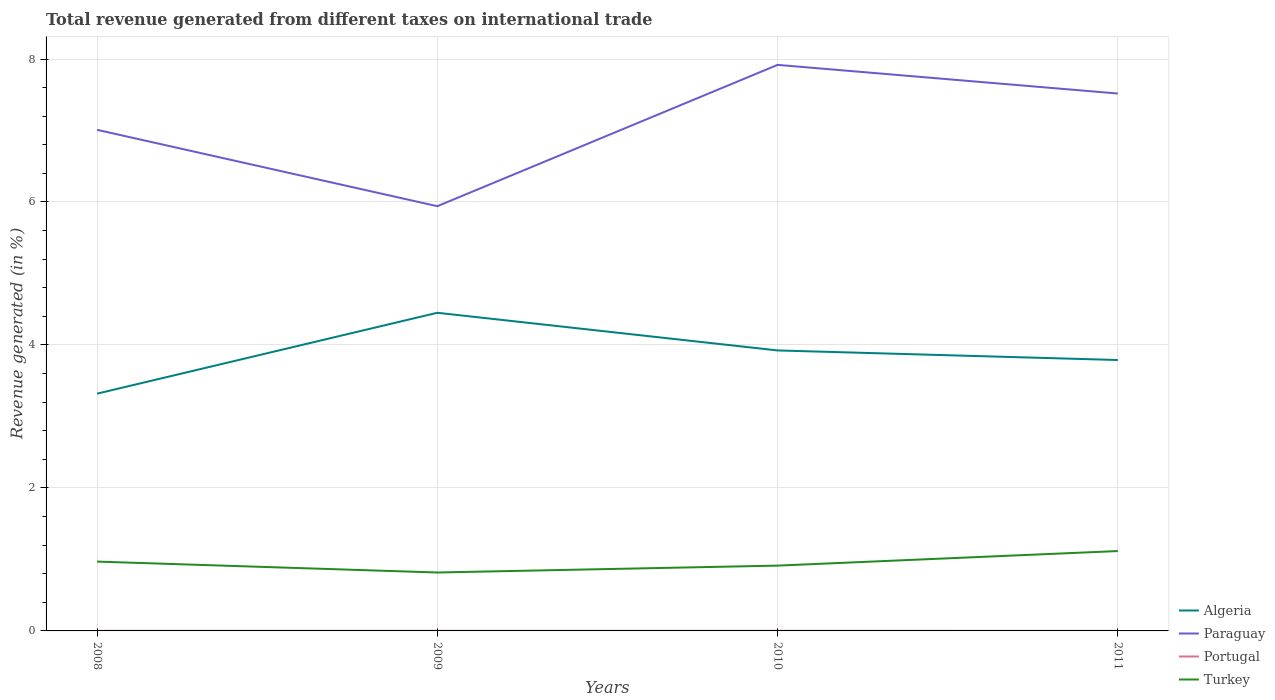How many different coloured lines are there?
Your answer should be compact. 4. Does the line corresponding to Portugal intersect with the line corresponding to Algeria?
Give a very brief answer. No. Across all years, what is the maximum total revenue generated in Paraguay?
Your answer should be compact. 5.94. What is the total total revenue generated in Algeria in the graph?
Ensure brevity in your answer.  0.53. What is the difference between the highest and the second highest total revenue generated in Turkey?
Your answer should be compact. 0.3. What is the difference between the highest and the lowest total revenue generated in Paraguay?
Ensure brevity in your answer.  2. Is the total revenue generated in Algeria strictly greater than the total revenue generated in Paraguay over the years?
Provide a succinct answer. Yes. How many lines are there?
Your response must be concise. 4. How many years are there in the graph?
Offer a very short reply. 4. Are the values on the major ticks of Y-axis written in scientific E-notation?
Your answer should be compact. No. Does the graph contain grids?
Give a very brief answer. Yes. Where does the legend appear in the graph?
Provide a succinct answer. Bottom right. How many legend labels are there?
Offer a very short reply. 4. How are the legend labels stacked?
Provide a succinct answer. Vertical. What is the title of the graph?
Provide a short and direct response. Total revenue generated from different taxes on international trade. Does "Austria" appear as one of the legend labels in the graph?
Offer a very short reply. No. What is the label or title of the X-axis?
Provide a short and direct response. Years. What is the label or title of the Y-axis?
Offer a very short reply. Revenue generated (in %). What is the Revenue generated (in %) of Algeria in 2008?
Your answer should be very brief. 3.32. What is the Revenue generated (in %) of Paraguay in 2008?
Ensure brevity in your answer.  7.01. What is the Revenue generated (in %) of Portugal in 2008?
Offer a terse response. 0. What is the Revenue generated (in %) in Turkey in 2008?
Provide a succinct answer. 0.97. What is the Revenue generated (in %) of Algeria in 2009?
Provide a succinct answer. 4.45. What is the Revenue generated (in %) in Paraguay in 2009?
Your answer should be compact. 5.94. What is the Revenue generated (in %) in Portugal in 2009?
Your answer should be compact. 0. What is the Revenue generated (in %) in Turkey in 2009?
Your response must be concise. 0.82. What is the Revenue generated (in %) of Algeria in 2010?
Give a very brief answer. 3.92. What is the Revenue generated (in %) in Paraguay in 2010?
Your answer should be compact. 7.92. What is the Revenue generated (in %) of Portugal in 2010?
Give a very brief answer. 0. What is the Revenue generated (in %) in Turkey in 2010?
Your answer should be very brief. 0.91. What is the Revenue generated (in %) of Algeria in 2011?
Offer a very short reply. 3.79. What is the Revenue generated (in %) of Paraguay in 2011?
Your response must be concise. 7.52. What is the Revenue generated (in %) in Portugal in 2011?
Offer a very short reply. 0. What is the Revenue generated (in %) in Turkey in 2011?
Your response must be concise. 1.12. Across all years, what is the maximum Revenue generated (in %) in Algeria?
Your answer should be very brief. 4.45. Across all years, what is the maximum Revenue generated (in %) of Paraguay?
Provide a short and direct response. 7.92. Across all years, what is the maximum Revenue generated (in %) of Portugal?
Ensure brevity in your answer.  0. Across all years, what is the maximum Revenue generated (in %) of Turkey?
Keep it short and to the point. 1.12. Across all years, what is the minimum Revenue generated (in %) in Algeria?
Give a very brief answer. 3.32. Across all years, what is the minimum Revenue generated (in %) of Paraguay?
Offer a terse response. 5.94. Across all years, what is the minimum Revenue generated (in %) in Portugal?
Make the answer very short. 0. Across all years, what is the minimum Revenue generated (in %) of Turkey?
Provide a succinct answer. 0.82. What is the total Revenue generated (in %) of Algeria in the graph?
Your response must be concise. 15.48. What is the total Revenue generated (in %) of Paraguay in the graph?
Offer a terse response. 28.39. What is the total Revenue generated (in %) of Portugal in the graph?
Keep it short and to the point. 0.01. What is the total Revenue generated (in %) of Turkey in the graph?
Provide a succinct answer. 3.82. What is the difference between the Revenue generated (in %) of Algeria in 2008 and that in 2009?
Offer a very short reply. -1.13. What is the difference between the Revenue generated (in %) in Paraguay in 2008 and that in 2009?
Make the answer very short. 1.07. What is the difference between the Revenue generated (in %) in Portugal in 2008 and that in 2009?
Keep it short and to the point. 0. What is the difference between the Revenue generated (in %) of Turkey in 2008 and that in 2009?
Offer a terse response. 0.15. What is the difference between the Revenue generated (in %) of Algeria in 2008 and that in 2010?
Your response must be concise. -0.6. What is the difference between the Revenue generated (in %) of Paraguay in 2008 and that in 2010?
Give a very brief answer. -0.91. What is the difference between the Revenue generated (in %) of Turkey in 2008 and that in 2010?
Give a very brief answer. 0.06. What is the difference between the Revenue generated (in %) in Algeria in 2008 and that in 2011?
Keep it short and to the point. -0.47. What is the difference between the Revenue generated (in %) of Paraguay in 2008 and that in 2011?
Give a very brief answer. -0.51. What is the difference between the Revenue generated (in %) of Portugal in 2008 and that in 2011?
Keep it short and to the point. 0. What is the difference between the Revenue generated (in %) in Turkey in 2008 and that in 2011?
Offer a very short reply. -0.15. What is the difference between the Revenue generated (in %) of Algeria in 2009 and that in 2010?
Make the answer very short. 0.53. What is the difference between the Revenue generated (in %) of Paraguay in 2009 and that in 2010?
Your answer should be very brief. -1.98. What is the difference between the Revenue generated (in %) in Turkey in 2009 and that in 2010?
Your answer should be very brief. -0.1. What is the difference between the Revenue generated (in %) in Algeria in 2009 and that in 2011?
Provide a succinct answer. 0.66. What is the difference between the Revenue generated (in %) in Paraguay in 2009 and that in 2011?
Your answer should be very brief. -1.58. What is the difference between the Revenue generated (in %) of Portugal in 2009 and that in 2011?
Make the answer very short. 0. What is the difference between the Revenue generated (in %) in Turkey in 2009 and that in 2011?
Keep it short and to the point. -0.3. What is the difference between the Revenue generated (in %) of Algeria in 2010 and that in 2011?
Your answer should be very brief. 0.13. What is the difference between the Revenue generated (in %) of Paraguay in 2010 and that in 2011?
Keep it short and to the point. 0.4. What is the difference between the Revenue generated (in %) of Portugal in 2010 and that in 2011?
Provide a short and direct response. 0. What is the difference between the Revenue generated (in %) in Turkey in 2010 and that in 2011?
Make the answer very short. -0.2. What is the difference between the Revenue generated (in %) of Algeria in 2008 and the Revenue generated (in %) of Paraguay in 2009?
Make the answer very short. -2.62. What is the difference between the Revenue generated (in %) in Algeria in 2008 and the Revenue generated (in %) in Portugal in 2009?
Offer a terse response. 3.32. What is the difference between the Revenue generated (in %) in Algeria in 2008 and the Revenue generated (in %) in Turkey in 2009?
Give a very brief answer. 2.5. What is the difference between the Revenue generated (in %) of Paraguay in 2008 and the Revenue generated (in %) of Portugal in 2009?
Your response must be concise. 7.01. What is the difference between the Revenue generated (in %) in Paraguay in 2008 and the Revenue generated (in %) in Turkey in 2009?
Ensure brevity in your answer.  6.19. What is the difference between the Revenue generated (in %) of Portugal in 2008 and the Revenue generated (in %) of Turkey in 2009?
Give a very brief answer. -0.82. What is the difference between the Revenue generated (in %) in Algeria in 2008 and the Revenue generated (in %) in Paraguay in 2010?
Offer a terse response. -4.6. What is the difference between the Revenue generated (in %) in Algeria in 2008 and the Revenue generated (in %) in Portugal in 2010?
Your answer should be compact. 3.32. What is the difference between the Revenue generated (in %) of Algeria in 2008 and the Revenue generated (in %) of Turkey in 2010?
Provide a short and direct response. 2.41. What is the difference between the Revenue generated (in %) of Paraguay in 2008 and the Revenue generated (in %) of Portugal in 2010?
Your answer should be very brief. 7.01. What is the difference between the Revenue generated (in %) in Paraguay in 2008 and the Revenue generated (in %) in Turkey in 2010?
Give a very brief answer. 6.1. What is the difference between the Revenue generated (in %) of Portugal in 2008 and the Revenue generated (in %) of Turkey in 2010?
Provide a short and direct response. -0.91. What is the difference between the Revenue generated (in %) in Algeria in 2008 and the Revenue generated (in %) in Paraguay in 2011?
Keep it short and to the point. -4.2. What is the difference between the Revenue generated (in %) in Algeria in 2008 and the Revenue generated (in %) in Portugal in 2011?
Give a very brief answer. 3.32. What is the difference between the Revenue generated (in %) of Algeria in 2008 and the Revenue generated (in %) of Turkey in 2011?
Provide a short and direct response. 2.2. What is the difference between the Revenue generated (in %) in Paraguay in 2008 and the Revenue generated (in %) in Portugal in 2011?
Provide a succinct answer. 7.01. What is the difference between the Revenue generated (in %) in Paraguay in 2008 and the Revenue generated (in %) in Turkey in 2011?
Your answer should be very brief. 5.89. What is the difference between the Revenue generated (in %) in Portugal in 2008 and the Revenue generated (in %) in Turkey in 2011?
Ensure brevity in your answer.  -1.12. What is the difference between the Revenue generated (in %) in Algeria in 2009 and the Revenue generated (in %) in Paraguay in 2010?
Ensure brevity in your answer.  -3.47. What is the difference between the Revenue generated (in %) in Algeria in 2009 and the Revenue generated (in %) in Portugal in 2010?
Your answer should be compact. 4.45. What is the difference between the Revenue generated (in %) in Algeria in 2009 and the Revenue generated (in %) in Turkey in 2010?
Keep it short and to the point. 3.54. What is the difference between the Revenue generated (in %) in Paraguay in 2009 and the Revenue generated (in %) in Portugal in 2010?
Your answer should be very brief. 5.94. What is the difference between the Revenue generated (in %) of Paraguay in 2009 and the Revenue generated (in %) of Turkey in 2010?
Your answer should be very brief. 5.03. What is the difference between the Revenue generated (in %) of Portugal in 2009 and the Revenue generated (in %) of Turkey in 2010?
Provide a short and direct response. -0.91. What is the difference between the Revenue generated (in %) in Algeria in 2009 and the Revenue generated (in %) in Paraguay in 2011?
Keep it short and to the point. -3.07. What is the difference between the Revenue generated (in %) of Algeria in 2009 and the Revenue generated (in %) of Portugal in 2011?
Offer a terse response. 4.45. What is the difference between the Revenue generated (in %) of Algeria in 2009 and the Revenue generated (in %) of Turkey in 2011?
Offer a very short reply. 3.33. What is the difference between the Revenue generated (in %) in Paraguay in 2009 and the Revenue generated (in %) in Portugal in 2011?
Provide a short and direct response. 5.94. What is the difference between the Revenue generated (in %) in Paraguay in 2009 and the Revenue generated (in %) in Turkey in 2011?
Your answer should be compact. 4.82. What is the difference between the Revenue generated (in %) of Portugal in 2009 and the Revenue generated (in %) of Turkey in 2011?
Offer a terse response. -1.12. What is the difference between the Revenue generated (in %) in Algeria in 2010 and the Revenue generated (in %) in Paraguay in 2011?
Give a very brief answer. -3.59. What is the difference between the Revenue generated (in %) of Algeria in 2010 and the Revenue generated (in %) of Portugal in 2011?
Make the answer very short. 3.92. What is the difference between the Revenue generated (in %) in Algeria in 2010 and the Revenue generated (in %) in Turkey in 2011?
Your answer should be very brief. 2.81. What is the difference between the Revenue generated (in %) in Paraguay in 2010 and the Revenue generated (in %) in Portugal in 2011?
Provide a short and direct response. 7.92. What is the difference between the Revenue generated (in %) in Paraguay in 2010 and the Revenue generated (in %) in Turkey in 2011?
Provide a succinct answer. 6.8. What is the difference between the Revenue generated (in %) in Portugal in 2010 and the Revenue generated (in %) in Turkey in 2011?
Provide a succinct answer. -1.12. What is the average Revenue generated (in %) of Algeria per year?
Your response must be concise. 3.87. What is the average Revenue generated (in %) of Paraguay per year?
Provide a short and direct response. 7.1. What is the average Revenue generated (in %) of Portugal per year?
Your answer should be very brief. 0. What is the average Revenue generated (in %) in Turkey per year?
Provide a succinct answer. 0.95. In the year 2008, what is the difference between the Revenue generated (in %) of Algeria and Revenue generated (in %) of Paraguay?
Keep it short and to the point. -3.69. In the year 2008, what is the difference between the Revenue generated (in %) in Algeria and Revenue generated (in %) in Portugal?
Provide a short and direct response. 3.32. In the year 2008, what is the difference between the Revenue generated (in %) of Algeria and Revenue generated (in %) of Turkey?
Keep it short and to the point. 2.35. In the year 2008, what is the difference between the Revenue generated (in %) in Paraguay and Revenue generated (in %) in Portugal?
Keep it short and to the point. 7.01. In the year 2008, what is the difference between the Revenue generated (in %) in Paraguay and Revenue generated (in %) in Turkey?
Offer a terse response. 6.04. In the year 2008, what is the difference between the Revenue generated (in %) of Portugal and Revenue generated (in %) of Turkey?
Ensure brevity in your answer.  -0.97. In the year 2009, what is the difference between the Revenue generated (in %) of Algeria and Revenue generated (in %) of Paraguay?
Your answer should be very brief. -1.49. In the year 2009, what is the difference between the Revenue generated (in %) in Algeria and Revenue generated (in %) in Portugal?
Offer a terse response. 4.45. In the year 2009, what is the difference between the Revenue generated (in %) in Algeria and Revenue generated (in %) in Turkey?
Your response must be concise. 3.63. In the year 2009, what is the difference between the Revenue generated (in %) in Paraguay and Revenue generated (in %) in Portugal?
Your answer should be compact. 5.94. In the year 2009, what is the difference between the Revenue generated (in %) in Paraguay and Revenue generated (in %) in Turkey?
Your answer should be very brief. 5.12. In the year 2009, what is the difference between the Revenue generated (in %) of Portugal and Revenue generated (in %) of Turkey?
Your answer should be compact. -0.82. In the year 2010, what is the difference between the Revenue generated (in %) in Algeria and Revenue generated (in %) in Paraguay?
Give a very brief answer. -3.99. In the year 2010, what is the difference between the Revenue generated (in %) of Algeria and Revenue generated (in %) of Portugal?
Your response must be concise. 3.92. In the year 2010, what is the difference between the Revenue generated (in %) of Algeria and Revenue generated (in %) of Turkey?
Give a very brief answer. 3.01. In the year 2010, what is the difference between the Revenue generated (in %) of Paraguay and Revenue generated (in %) of Portugal?
Your response must be concise. 7.92. In the year 2010, what is the difference between the Revenue generated (in %) of Paraguay and Revenue generated (in %) of Turkey?
Ensure brevity in your answer.  7. In the year 2010, what is the difference between the Revenue generated (in %) in Portugal and Revenue generated (in %) in Turkey?
Provide a succinct answer. -0.91. In the year 2011, what is the difference between the Revenue generated (in %) of Algeria and Revenue generated (in %) of Paraguay?
Offer a very short reply. -3.73. In the year 2011, what is the difference between the Revenue generated (in %) in Algeria and Revenue generated (in %) in Portugal?
Your answer should be compact. 3.79. In the year 2011, what is the difference between the Revenue generated (in %) in Algeria and Revenue generated (in %) in Turkey?
Ensure brevity in your answer.  2.67. In the year 2011, what is the difference between the Revenue generated (in %) of Paraguay and Revenue generated (in %) of Portugal?
Your response must be concise. 7.52. In the year 2011, what is the difference between the Revenue generated (in %) in Paraguay and Revenue generated (in %) in Turkey?
Your answer should be compact. 6.4. In the year 2011, what is the difference between the Revenue generated (in %) in Portugal and Revenue generated (in %) in Turkey?
Keep it short and to the point. -1.12. What is the ratio of the Revenue generated (in %) in Algeria in 2008 to that in 2009?
Give a very brief answer. 0.75. What is the ratio of the Revenue generated (in %) of Paraguay in 2008 to that in 2009?
Your answer should be compact. 1.18. What is the ratio of the Revenue generated (in %) in Portugal in 2008 to that in 2009?
Offer a terse response. 1.04. What is the ratio of the Revenue generated (in %) of Turkey in 2008 to that in 2009?
Your response must be concise. 1.19. What is the ratio of the Revenue generated (in %) in Algeria in 2008 to that in 2010?
Your response must be concise. 0.85. What is the ratio of the Revenue generated (in %) of Paraguay in 2008 to that in 2010?
Offer a terse response. 0.89. What is the ratio of the Revenue generated (in %) of Portugal in 2008 to that in 2010?
Provide a succinct answer. 1.06. What is the ratio of the Revenue generated (in %) in Turkey in 2008 to that in 2010?
Your answer should be compact. 1.06. What is the ratio of the Revenue generated (in %) of Algeria in 2008 to that in 2011?
Ensure brevity in your answer.  0.88. What is the ratio of the Revenue generated (in %) of Paraguay in 2008 to that in 2011?
Your answer should be very brief. 0.93. What is the ratio of the Revenue generated (in %) in Portugal in 2008 to that in 2011?
Provide a succinct answer. 1.14. What is the ratio of the Revenue generated (in %) in Turkey in 2008 to that in 2011?
Provide a short and direct response. 0.87. What is the ratio of the Revenue generated (in %) of Algeria in 2009 to that in 2010?
Give a very brief answer. 1.13. What is the ratio of the Revenue generated (in %) in Paraguay in 2009 to that in 2010?
Provide a succinct answer. 0.75. What is the ratio of the Revenue generated (in %) in Portugal in 2009 to that in 2010?
Offer a terse response. 1.02. What is the ratio of the Revenue generated (in %) of Turkey in 2009 to that in 2010?
Make the answer very short. 0.89. What is the ratio of the Revenue generated (in %) of Algeria in 2009 to that in 2011?
Your answer should be very brief. 1.17. What is the ratio of the Revenue generated (in %) of Paraguay in 2009 to that in 2011?
Give a very brief answer. 0.79. What is the ratio of the Revenue generated (in %) in Portugal in 2009 to that in 2011?
Offer a very short reply. 1.1. What is the ratio of the Revenue generated (in %) of Turkey in 2009 to that in 2011?
Offer a terse response. 0.73. What is the ratio of the Revenue generated (in %) in Algeria in 2010 to that in 2011?
Provide a succinct answer. 1.04. What is the ratio of the Revenue generated (in %) in Paraguay in 2010 to that in 2011?
Ensure brevity in your answer.  1.05. What is the ratio of the Revenue generated (in %) in Portugal in 2010 to that in 2011?
Offer a very short reply. 1.08. What is the ratio of the Revenue generated (in %) in Turkey in 2010 to that in 2011?
Keep it short and to the point. 0.82. What is the difference between the highest and the second highest Revenue generated (in %) of Algeria?
Provide a short and direct response. 0.53. What is the difference between the highest and the second highest Revenue generated (in %) in Paraguay?
Make the answer very short. 0.4. What is the difference between the highest and the second highest Revenue generated (in %) of Turkey?
Ensure brevity in your answer.  0.15. What is the difference between the highest and the lowest Revenue generated (in %) of Algeria?
Offer a terse response. 1.13. What is the difference between the highest and the lowest Revenue generated (in %) in Paraguay?
Offer a terse response. 1.98. What is the difference between the highest and the lowest Revenue generated (in %) in Portugal?
Offer a very short reply. 0. What is the difference between the highest and the lowest Revenue generated (in %) of Turkey?
Keep it short and to the point. 0.3. 